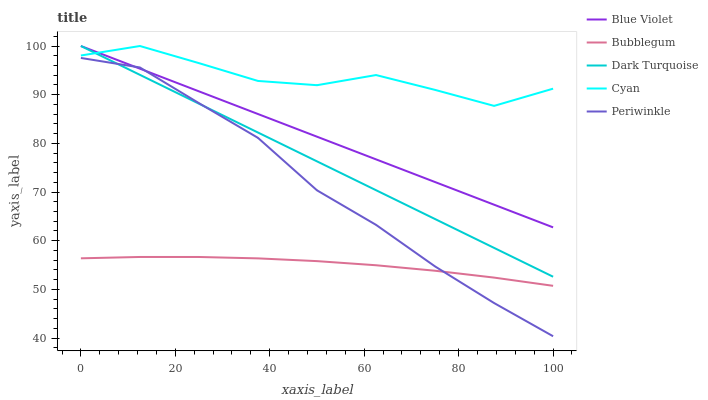Does Bubblegum have the minimum area under the curve?
Answer yes or no. Yes. Does Cyan have the maximum area under the curve?
Answer yes or no. Yes. Does Periwinkle have the minimum area under the curve?
Answer yes or no. No. Does Periwinkle have the maximum area under the curve?
Answer yes or no. No. Is Dark Turquoise the smoothest?
Answer yes or no. Yes. Is Cyan the roughest?
Answer yes or no. Yes. Is Periwinkle the smoothest?
Answer yes or no. No. Is Periwinkle the roughest?
Answer yes or no. No. Does Periwinkle have the lowest value?
Answer yes or no. Yes. Does Bubblegum have the lowest value?
Answer yes or no. No. Does Cyan have the highest value?
Answer yes or no. Yes. Does Periwinkle have the highest value?
Answer yes or no. No. Is Bubblegum less than Cyan?
Answer yes or no. Yes. Is Cyan greater than Bubblegum?
Answer yes or no. Yes. Does Dark Turquoise intersect Cyan?
Answer yes or no. Yes. Is Dark Turquoise less than Cyan?
Answer yes or no. No. Is Dark Turquoise greater than Cyan?
Answer yes or no. No. Does Bubblegum intersect Cyan?
Answer yes or no. No. 